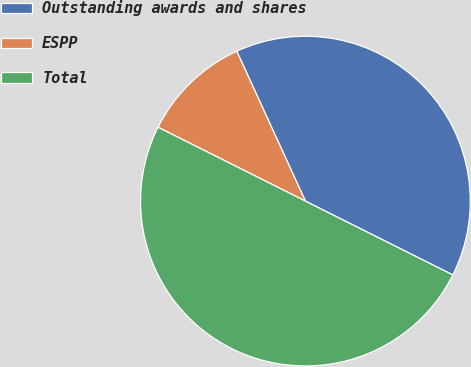Convert chart to OTSL. <chart><loc_0><loc_0><loc_500><loc_500><pie_chart><fcel>Outstanding awards and shares<fcel>ESPP<fcel>Total<nl><fcel>39.23%<fcel>10.77%<fcel>50.0%<nl></chart> 